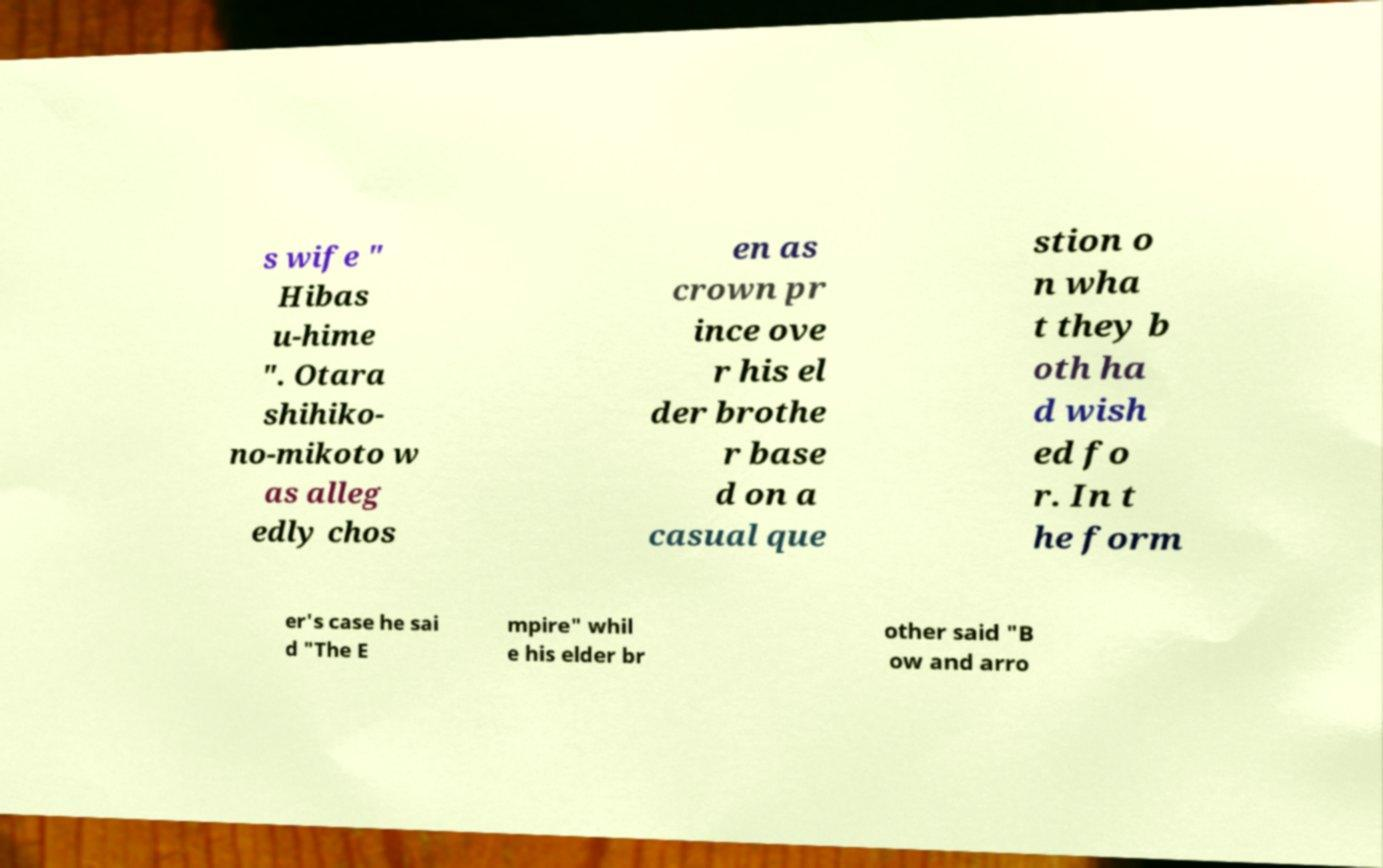Could you extract and type out the text from this image? s wife " Hibas u-hime ". Otara shihiko- no-mikoto w as alleg edly chos en as crown pr ince ove r his el der brothe r base d on a casual que stion o n wha t they b oth ha d wish ed fo r. In t he form er's case he sai d "The E mpire" whil e his elder br other said "B ow and arro 